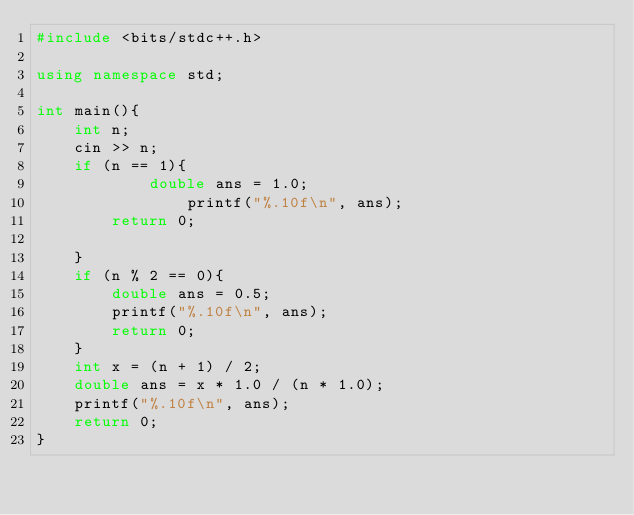<code> <loc_0><loc_0><loc_500><loc_500><_C++_>#include <bits/stdc++.h>

using namespace std;

int main(){
    int n;
    cin >> n;
    if (n == 1){
            double ans = 1.0;
                printf("%.10f\n", ans);
        return 0;

    }
    if (n % 2 == 0){
        double ans = 0.5;
        printf("%.10f\n", ans);
        return 0;
    }
    int x = (n + 1) / 2;
    double ans = x * 1.0 / (n * 1.0);
    printf("%.10f\n", ans);
    return 0;
}
</code> 